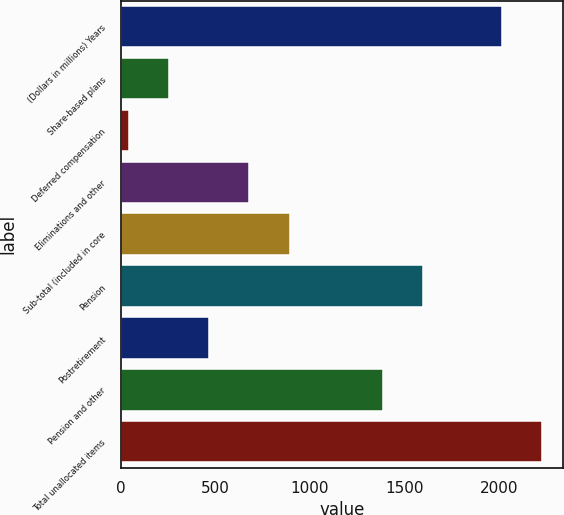<chart> <loc_0><loc_0><loc_500><loc_500><bar_chart><fcel>(Dollars in millions) Years<fcel>Share-based plans<fcel>Deferred compensation<fcel>Eliminations and other<fcel>Sub-total (included in core<fcel>Pension<fcel>Postretirement<fcel>Pension and other<fcel>Total unallocated items<nl><fcel>2014<fcel>255.9<fcel>44<fcel>679.7<fcel>891.6<fcel>1598.9<fcel>467.8<fcel>1387<fcel>2225.9<nl></chart> 